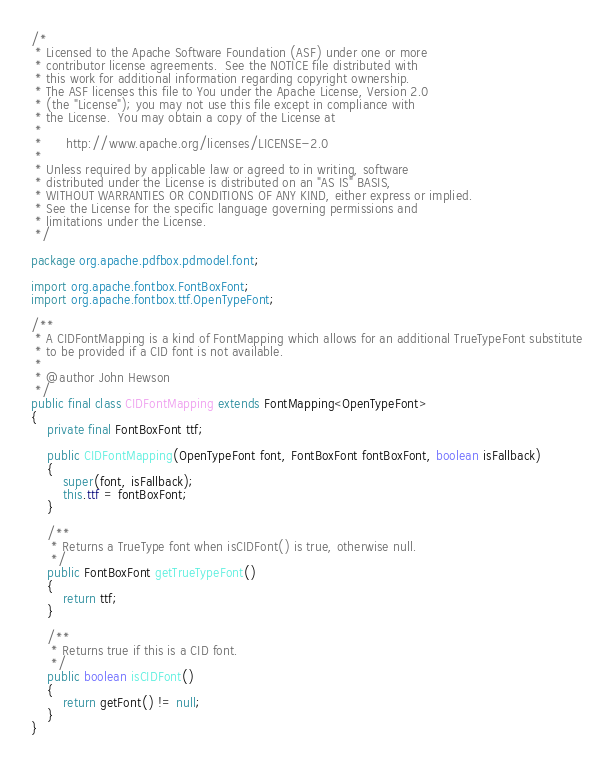<code> <loc_0><loc_0><loc_500><loc_500><_Java_>/*
 * Licensed to the Apache Software Foundation (ASF) under one or more
 * contributor license agreements.  See the NOTICE file distributed with
 * this work for additional information regarding copyright ownership.
 * The ASF licenses this file to You under the Apache License, Version 2.0
 * (the "License"); you may not use this file except in compliance with
 * the License.  You may obtain a copy of the License at
 *
 *      http://www.apache.org/licenses/LICENSE-2.0
 *
 * Unless required by applicable law or agreed to in writing, software
 * distributed under the License is distributed on an "AS IS" BASIS,
 * WITHOUT WARRANTIES OR CONDITIONS OF ANY KIND, either express or implied.
 * See the License for the specific language governing permissions and
 * limitations under the License.
 */

package org.apache.pdfbox.pdmodel.font;

import org.apache.fontbox.FontBoxFont;
import org.apache.fontbox.ttf.OpenTypeFont;

/**
 * A CIDFontMapping is a kind of FontMapping which allows for an additional TrueTypeFont substitute
 * to be provided if a CID font is not available.
 *
 * @author John Hewson
 */
public final class CIDFontMapping extends FontMapping<OpenTypeFont>
{
    private final FontBoxFont ttf;

    public CIDFontMapping(OpenTypeFont font, FontBoxFont fontBoxFont, boolean isFallback)
    {
        super(font, isFallback);
        this.ttf = fontBoxFont;
    }

    /**
     * Returns a TrueType font when isCIDFont() is true, otherwise null.
     */
    public FontBoxFont getTrueTypeFont()
    {
        return ttf;
    }

    /**
     * Returns true if this is a CID font.
     */
    public boolean isCIDFont()
    {
        return getFont() != null;
    }
}
</code> 